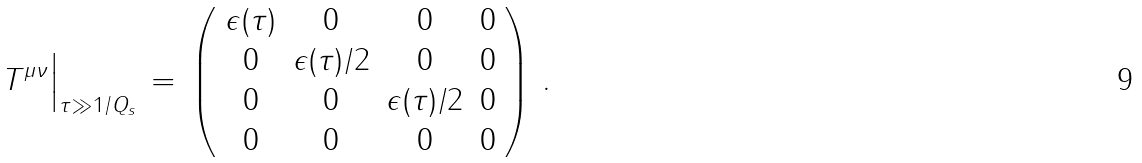<formula> <loc_0><loc_0><loc_500><loc_500>T ^ { \mu \nu } \Big | _ { \tau \gg 1 / Q _ { s } } \, = \, \left ( \begin{array} { c c c c } \epsilon ( \tau ) & 0 & 0 & 0 \\ 0 & \epsilon ( \tau ) / 2 & 0 & 0 \\ 0 & 0 & \epsilon ( \tau ) / 2 & 0 \\ 0 & 0 & 0 & 0 \end{array} \right ) \, .</formula> 